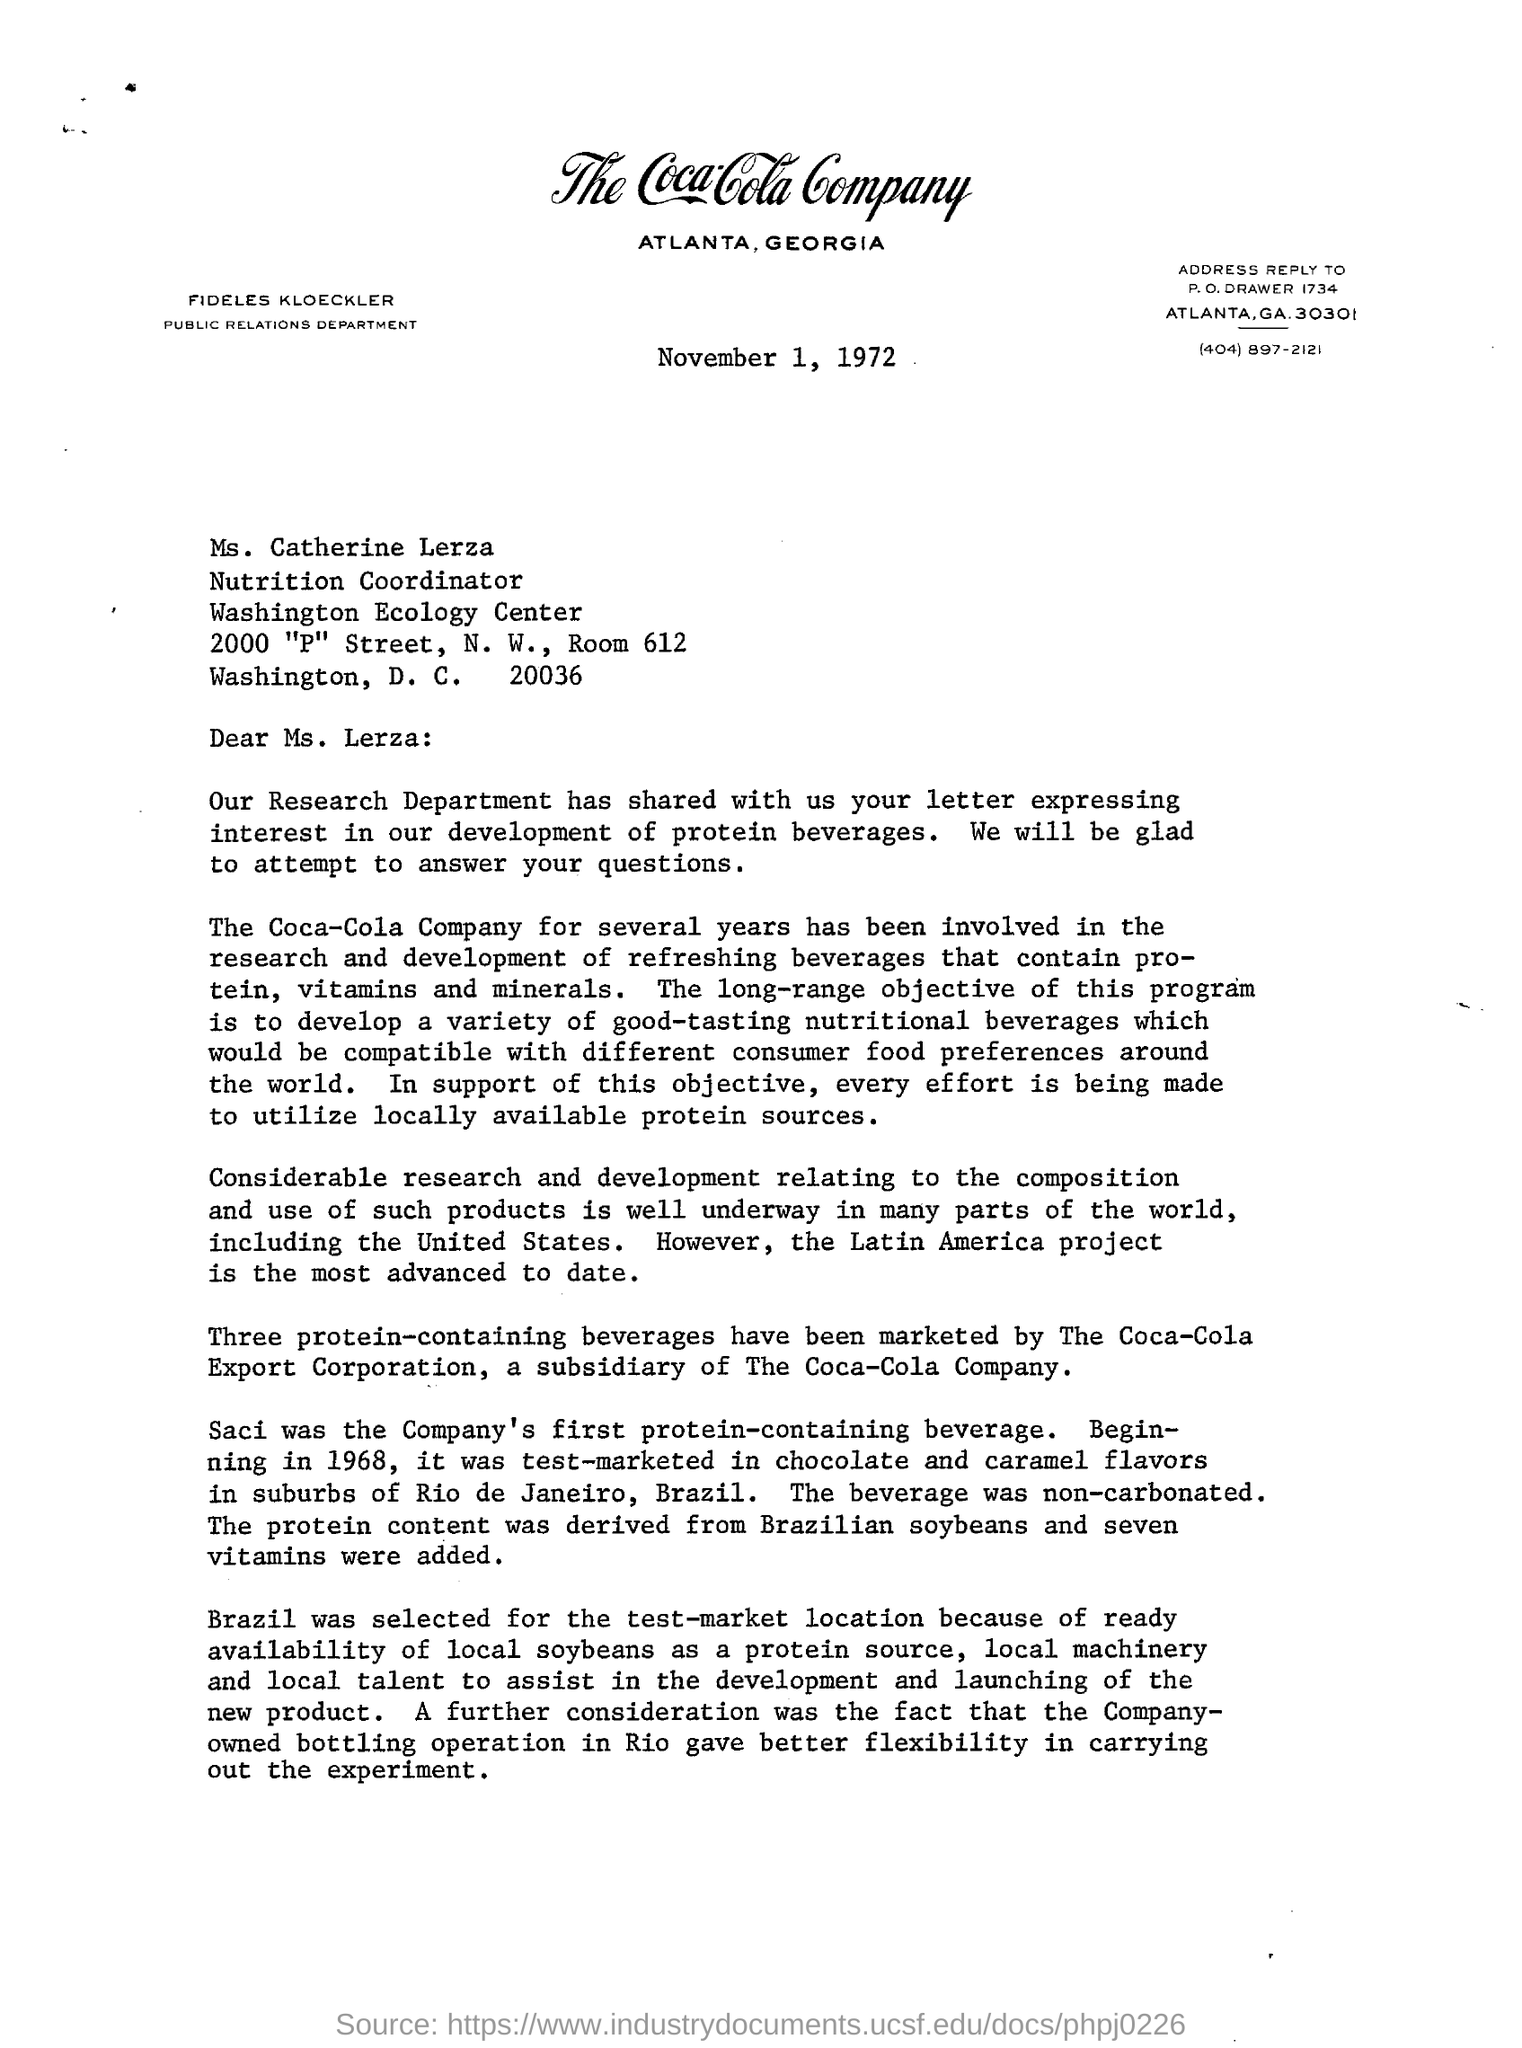Highlight a few significant elements in this photo. The letter is addressed to Ms. Lerza. The place where Coca-Cola Company is mentioned on the letterhead is Atlanta, Georgia. The company's first protein-containing beverage was Saci. 